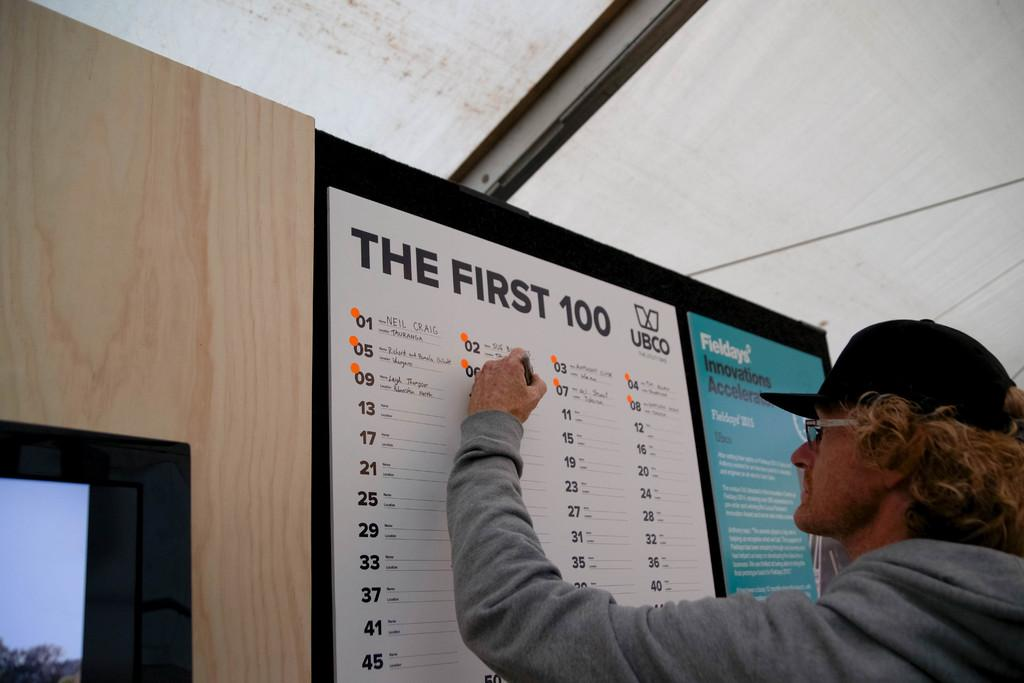<image>
Present a compact description of the photo's key features. A man writing on a board labelled the first 100. 